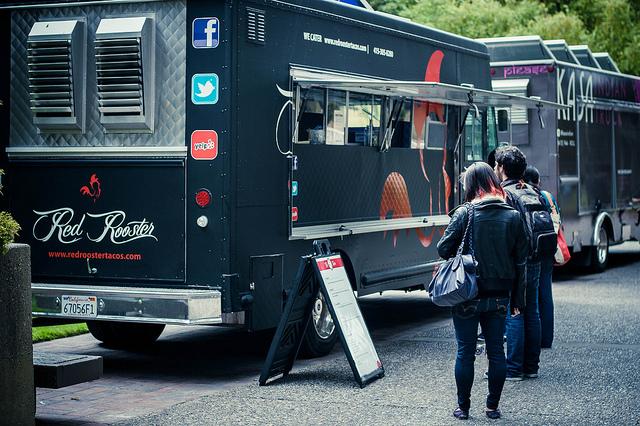What color is the Red Rooster truck?
Write a very short answer. Black. What are these people waiting in line for?
Write a very short answer. Food. Which three social network badges are posted on the back of the truck?
Give a very brief answer. Facebook, twitter, foursquare. 